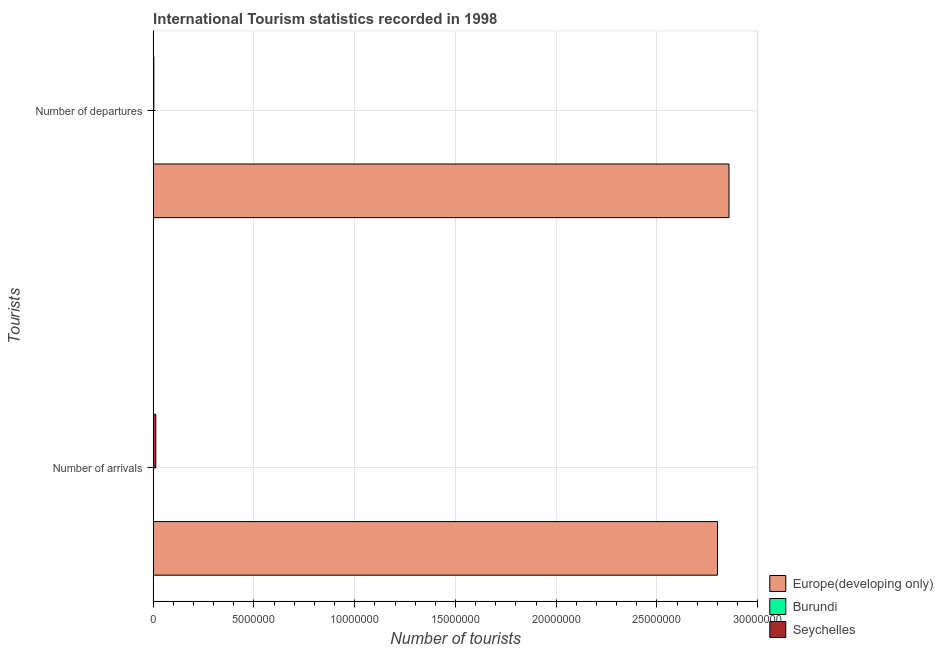How many groups of bars are there?
Your answer should be very brief. 2. How many bars are there on the 2nd tick from the top?
Make the answer very short. 3. How many bars are there on the 1st tick from the bottom?
Give a very brief answer. 3. What is the label of the 2nd group of bars from the top?
Ensure brevity in your answer.  Number of arrivals. What is the number of tourist arrivals in Seychelles?
Your answer should be compact. 1.28e+05. Across all countries, what is the maximum number of tourist departures?
Your answer should be very brief. 2.86e+07. Across all countries, what is the minimum number of tourist departures?
Ensure brevity in your answer.  1.60e+04. In which country was the number of tourist arrivals maximum?
Your response must be concise. Europe(developing only). In which country was the number of tourist arrivals minimum?
Your response must be concise. Burundi. What is the total number of tourist departures in the graph?
Offer a very short reply. 2.86e+07. What is the difference between the number of tourist departures in Seychelles and that in Europe(developing only)?
Provide a short and direct response. -2.85e+07. What is the difference between the number of tourist departures in Seychelles and the number of tourist arrivals in Burundi?
Provide a succinct answer. 1.60e+04. What is the average number of tourist arrivals per country?
Provide a short and direct response. 9.38e+06. What is the difference between the number of tourist departures and number of tourist arrivals in Burundi?
Offer a terse response. 1000. In how many countries, is the number of tourist arrivals greater than 13000000 ?
Offer a terse response. 1. What is the ratio of the number of tourist arrivals in Europe(developing only) to that in Seychelles?
Offer a terse response. 218.79. In how many countries, is the number of tourist arrivals greater than the average number of tourist arrivals taken over all countries?
Make the answer very short. 1. What does the 1st bar from the top in Number of departures represents?
Your response must be concise. Seychelles. What does the 2nd bar from the bottom in Number of arrivals represents?
Offer a very short reply. Burundi. Does the graph contain any zero values?
Give a very brief answer. No. Does the graph contain grids?
Your response must be concise. Yes. Where does the legend appear in the graph?
Keep it short and to the point. Bottom right. How many legend labels are there?
Ensure brevity in your answer.  3. How are the legend labels stacked?
Give a very brief answer. Vertical. What is the title of the graph?
Give a very brief answer. International Tourism statistics recorded in 1998. What is the label or title of the X-axis?
Give a very brief answer. Number of tourists. What is the label or title of the Y-axis?
Ensure brevity in your answer.  Tourists. What is the Number of tourists of Europe(developing only) in Number of arrivals?
Your answer should be very brief. 2.80e+07. What is the Number of tourists of Burundi in Number of arrivals?
Provide a succinct answer. 1.50e+04. What is the Number of tourists of Seychelles in Number of arrivals?
Make the answer very short. 1.28e+05. What is the Number of tourists in Europe(developing only) in Number of departures?
Provide a succinct answer. 2.86e+07. What is the Number of tourists in Burundi in Number of departures?
Your response must be concise. 1.60e+04. What is the Number of tourists of Seychelles in Number of departures?
Ensure brevity in your answer.  3.10e+04. Across all Tourists, what is the maximum Number of tourists of Europe(developing only)?
Offer a terse response. 2.86e+07. Across all Tourists, what is the maximum Number of tourists of Burundi?
Your response must be concise. 1.60e+04. Across all Tourists, what is the maximum Number of tourists in Seychelles?
Keep it short and to the point. 1.28e+05. Across all Tourists, what is the minimum Number of tourists of Europe(developing only)?
Provide a short and direct response. 2.80e+07. Across all Tourists, what is the minimum Number of tourists of Burundi?
Keep it short and to the point. 1.50e+04. Across all Tourists, what is the minimum Number of tourists in Seychelles?
Your answer should be compact. 3.10e+04. What is the total Number of tourists of Europe(developing only) in the graph?
Make the answer very short. 5.66e+07. What is the total Number of tourists in Burundi in the graph?
Your answer should be compact. 3.10e+04. What is the total Number of tourists in Seychelles in the graph?
Keep it short and to the point. 1.59e+05. What is the difference between the Number of tourists in Europe(developing only) in Number of arrivals and that in Number of departures?
Provide a succinct answer. -5.69e+05. What is the difference between the Number of tourists of Burundi in Number of arrivals and that in Number of departures?
Make the answer very short. -1000. What is the difference between the Number of tourists of Seychelles in Number of arrivals and that in Number of departures?
Provide a succinct answer. 9.70e+04. What is the difference between the Number of tourists of Europe(developing only) in Number of arrivals and the Number of tourists of Burundi in Number of departures?
Ensure brevity in your answer.  2.80e+07. What is the difference between the Number of tourists of Europe(developing only) in Number of arrivals and the Number of tourists of Seychelles in Number of departures?
Offer a very short reply. 2.80e+07. What is the difference between the Number of tourists in Burundi in Number of arrivals and the Number of tourists in Seychelles in Number of departures?
Offer a very short reply. -1.60e+04. What is the average Number of tourists of Europe(developing only) per Tourists?
Your answer should be compact. 2.83e+07. What is the average Number of tourists in Burundi per Tourists?
Ensure brevity in your answer.  1.55e+04. What is the average Number of tourists in Seychelles per Tourists?
Provide a short and direct response. 7.95e+04. What is the difference between the Number of tourists of Europe(developing only) and Number of tourists of Burundi in Number of arrivals?
Your answer should be very brief. 2.80e+07. What is the difference between the Number of tourists of Europe(developing only) and Number of tourists of Seychelles in Number of arrivals?
Make the answer very short. 2.79e+07. What is the difference between the Number of tourists in Burundi and Number of tourists in Seychelles in Number of arrivals?
Make the answer very short. -1.13e+05. What is the difference between the Number of tourists of Europe(developing only) and Number of tourists of Burundi in Number of departures?
Ensure brevity in your answer.  2.86e+07. What is the difference between the Number of tourists of Europe(developing only) and Number of tourists of Seychelles in Number of departures?
Give a very brief answer. 2.85e+07. What is the difference between the Number of tourists in Burundi and Number of tourists in Seychelles in Number of departures?
Make the answer very short. -1.50e+04. What is the ratio of the Number of tourists of Europe(developing only) in Number of arrivals to that in Number of departures?
Offer a very short reply. 0.98. What is the ratio of the Number of tourists of Seychelles in Number of arrivals to that in Number of departures?
Give a very brief answer. 4.13. What is the difference between the highest and the second highest Number of tourists of Europe(developing only)?
Your answer should be compact. 5.69e+05. What is the difference between the highest and the second highest Number of tourists in Burundi?
Your answer should be compact. 1000. What is the difference between the highest and the second highest Number of tourists in Seychelles?
Your answer should be very brief. 9.70e+04. What is the difference between the highest and the lowest Number of tourists in Europe(developing only)?
Ensure brevity in your answer.  5.69e+05. What is the difference between the highest and the lowest Number of tourists in Seychelles?
Ensure brevity in your answer.  9.70e+04. 